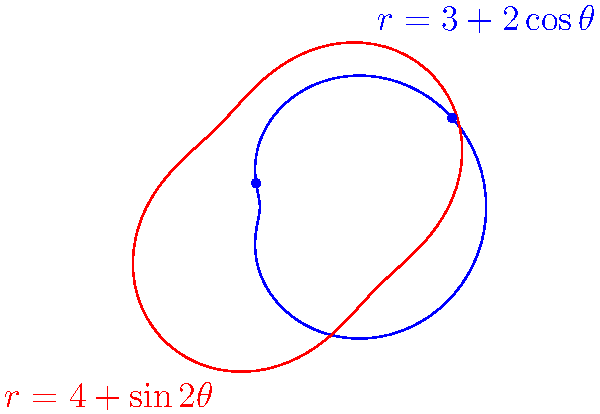Two competing business trends are represented by the polar curves $r=3+2\cos\theta$ and $r=4+\sin2\theta$. Find the $\theta$ values (in radians) for the intersection points of these curves in the interval $[0, 2\pi]$. To find the intersection points, we need to solve the equation:

$$3+2\cos\theta = 4+\sin2\theta$$

Step 1: Simplify the right side using the double angle formula for sine:
$$3+2\cos\theta = 4+2\sin\theta\cos\theta$$

Step 2: Rearrange the equation:
$$2\cos\theta - 2\sin\theta\cos\theta - 1 = 0$$

Step 3: Factor out $\cos\theta$:
$$\cos\theta(2 - 2\sin\theta) - 1 = 0$$

Step 4: Substitute $u = \sin\theta$:
$$(1-u^2)(2-2u) - 1 = 0$$

Step 5: Expand the equation:
$$2-2u-2u+2u^2-1 = 0$$
$$2u^2-4u+1 = 0$$

Step 6: Solve the quadratic equation:
$$u = \frac{4 \pm \sqrt{16-8}}{4} = \frac{4 \pm \sqrt{8}}{4} = \frac{4 \pm 2\sqrt{2}}{4} = 1 \pm \frac{\sqrt{2}}{2}$$

Step 7: The solutions are:
$$u_1 = \sin\theta_1 = 1 + \frac{\sqrt{2}}{2} \approx 1.707$$
$$u_2 = \sin\theta_2 = 1 - \frac{\sqrt{2}}{2} \approx 0.293$$

Step 8: Find $\theta$ values:
$$\theta_1 = \arcsin(1 + \frac{\sqrt{2}}{2}) \approx 1.571 \approx \frac{\pi}{2}$$
$$\theta_2 = \arcsin(1 - \frac{\sqrt{2}}{2}) \approx 0.304$$
$$\theta_3 = \pi - \theta_2 \approx 2.838 \approx \frac{5\pi}{6}$$

Therefore, the intersection points occur at $\theta \approx 0.304$ and $\theta \approx 2.838$ radians.
Answer: $\theta \approx 0.304$ and $\theta \approx 2.838$ radians 